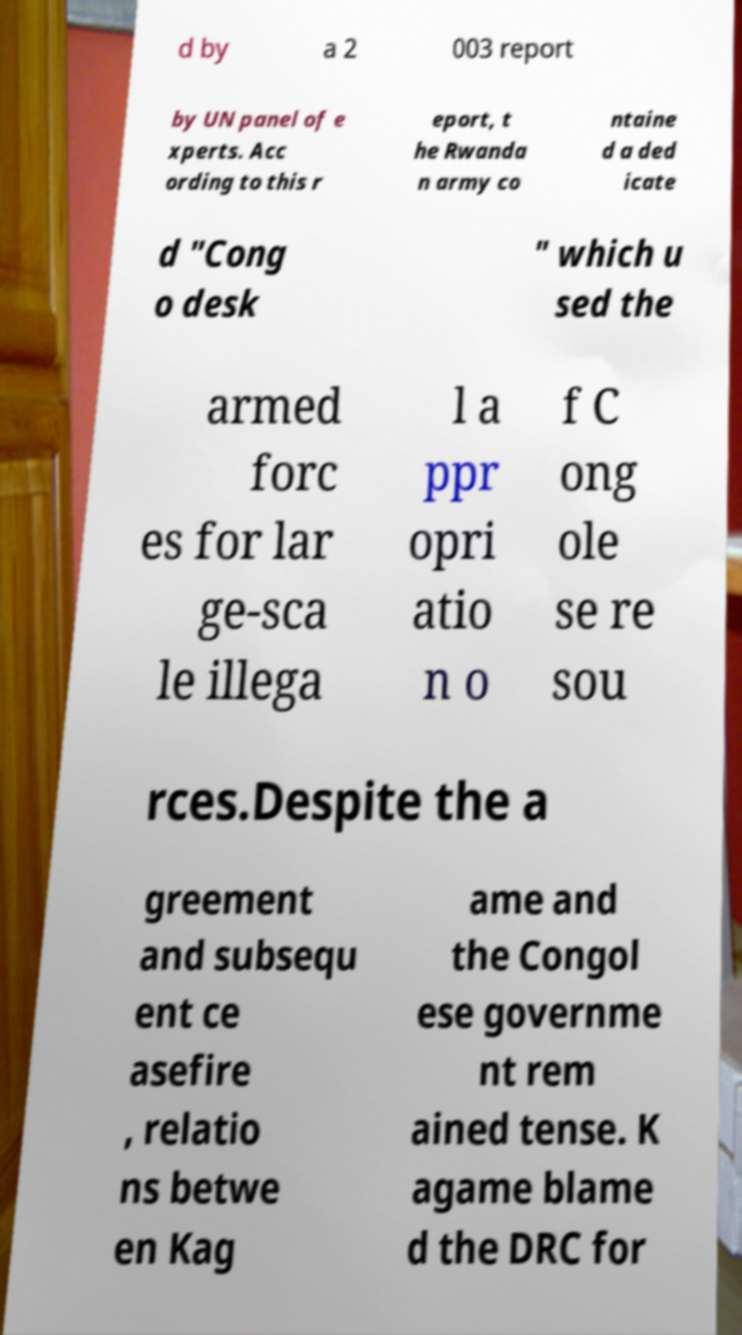I need the written content from this picture converted into text. Can you do that? d by a 2 003 report by UN panel of e xperts. Acc ording to this r eport, t he Rwanda n army co ntaine d a ded icate d "Cong o desk " which u sed the armed forc es for lar ge-sca le illega l a ppr opri atio n o f C ong ole se re sou rces.Despite the a greement and subsequ ent ce asefire , relatio ns betwe en Kag ame and the Congol ese governme nt rem ained tense. K agame blame d the DRC for 